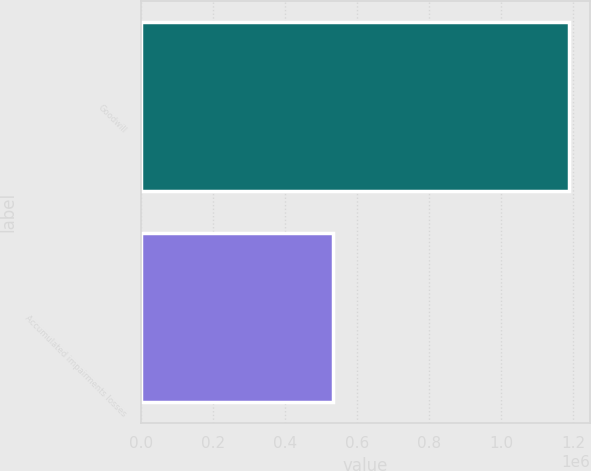Convert chart. <chart><loc_0><loc_0><loc_500><loc_500><bar_chart><fcel>Goodwill<fcel>Accumulated impairments losses<nl><fcel>1.18691e+06<fcel>531930<nl></chart> 